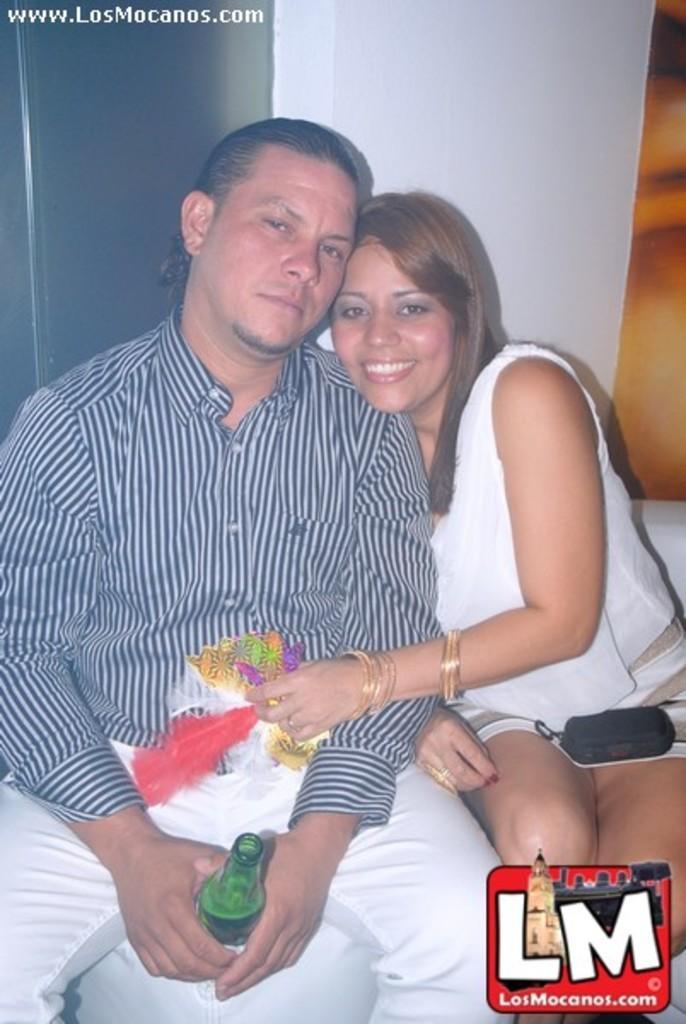Please provide a concise description of this image. Here in this picture we can see a man with blue lines shirt and a white pant. He is holding a bottle in his hands. Beside him there is a lady. She is wearing a bangle to her left hand and a ring to her right hand ring finger. There is a black color pouch on her lapse. The lady is smiling. They both are leaning to the pillar. 